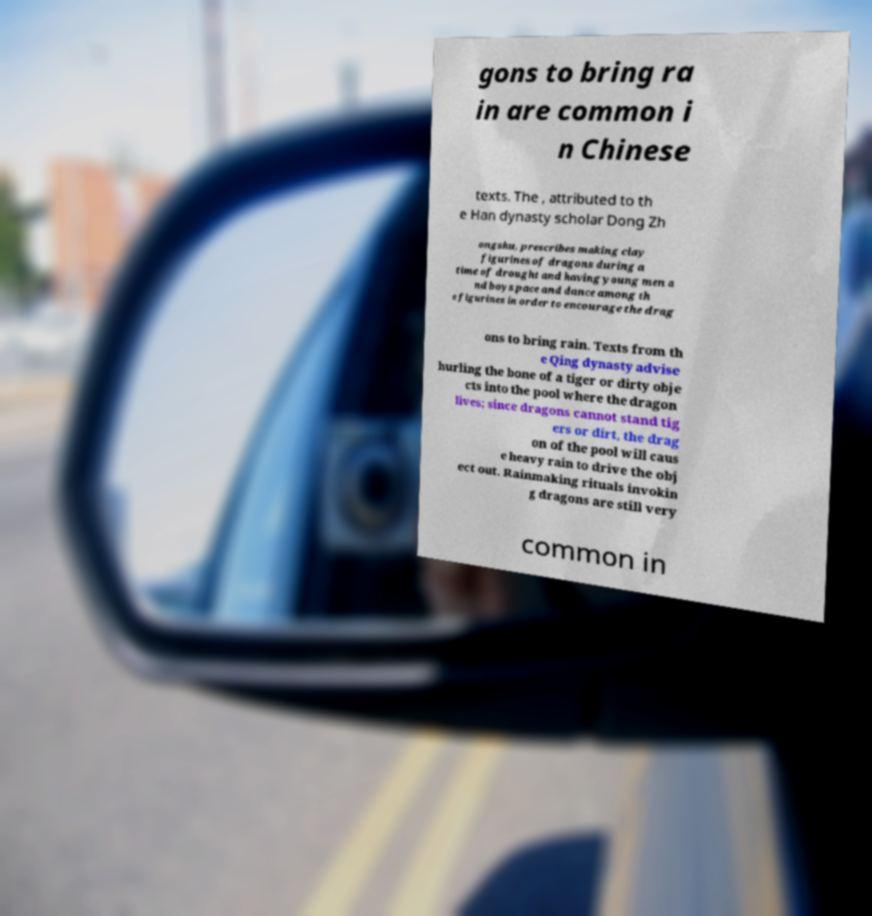Please identify and transcribe the text found in this image. gons to bring ra in are common i n Chinese texts. The , attributed to th e Han dynasty scholar Dong Zh ongshu, prescribes making clay figurines of dragons during a time of drought and having young men a nd boys pace and dance among th e figurines in order to encourage the drag ons to bring rain. Texts from th e Qing dynasty advise hurling the bone of a tiger or dirty obje cts into the pool where the dragon lives; since dragons cannot stand tig ers or dirt, the drag on of the pool will caus e heavy rain to drive the obj ect out. Rainmaking rituals invokin g dragons are still very common in 